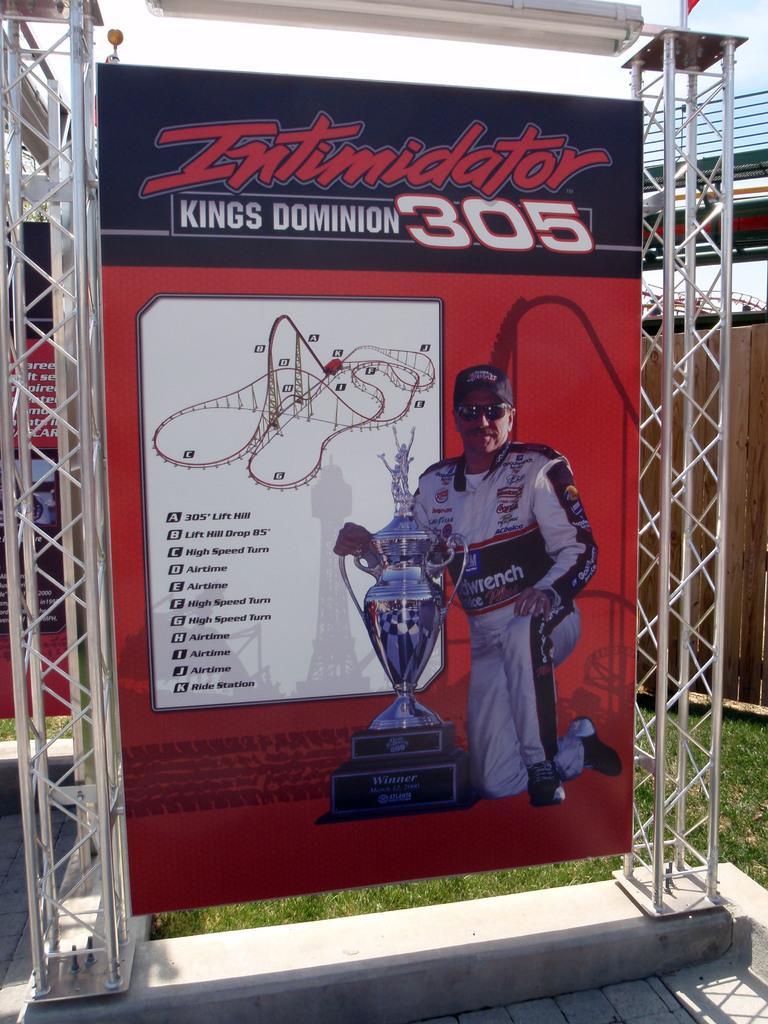<image>
Create a compact narrative representing the image presented. A sign for the Intimidator roller coaster ride. 